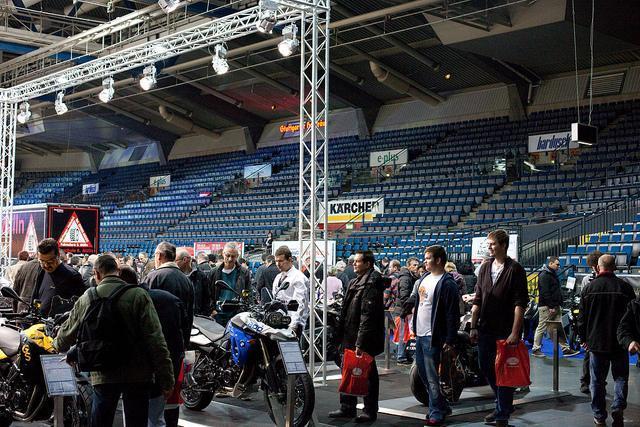How many motorcycles are there?
Give a very brief answer. 2. How many people are in the picture?
Give a very brief answer. 8. 